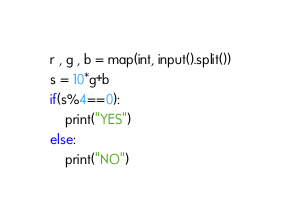Convert code to text. <code><loc_0><loc_0><loc_500><loc_500><_Python_>r , g , b = map(int, input().split())
s = 10*g+b
if(s%4==0):
    print("YES")
else:
    print("NO")</code> 